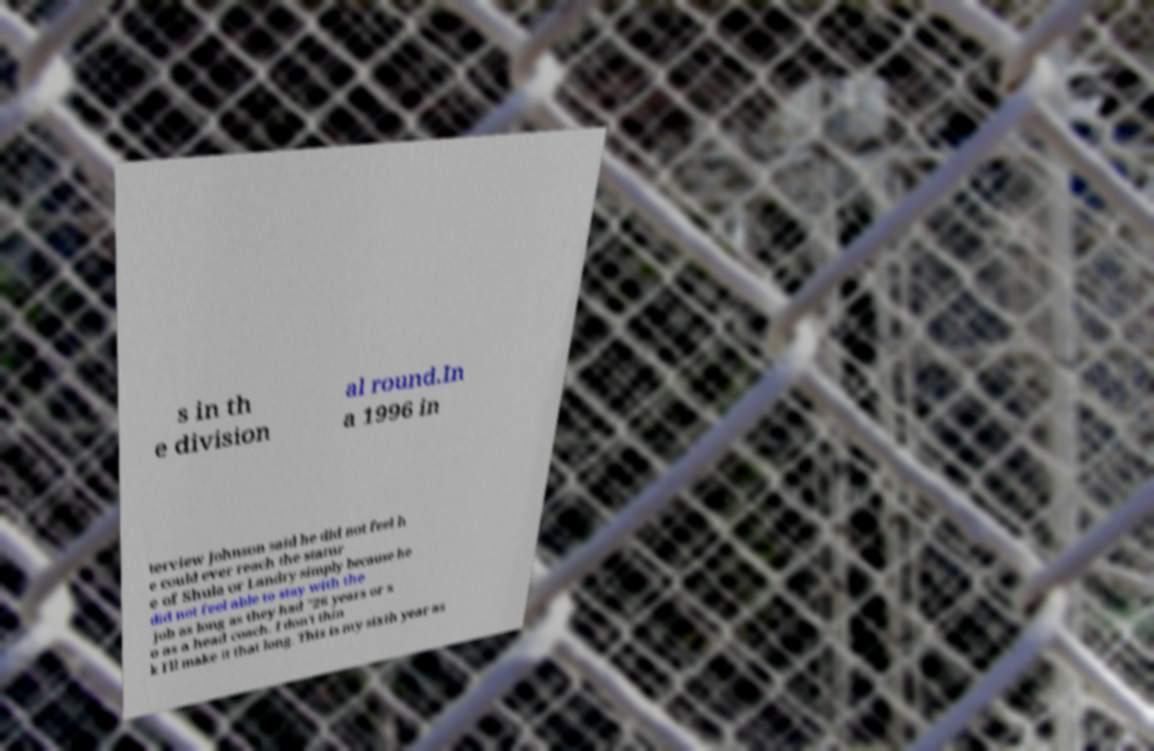For documentation purposes, I need the text within this image transcribed. Could you provide that? s in th e division al round.In a 1996 in terview Johnson said he did not feel h e could ever reach the statur e of Shula or Landry simply because he did not feel able to stay with the job as long as they had "26 years or s o as a head coach. I don't thin k I'll make it that long. This is my sixth year as 